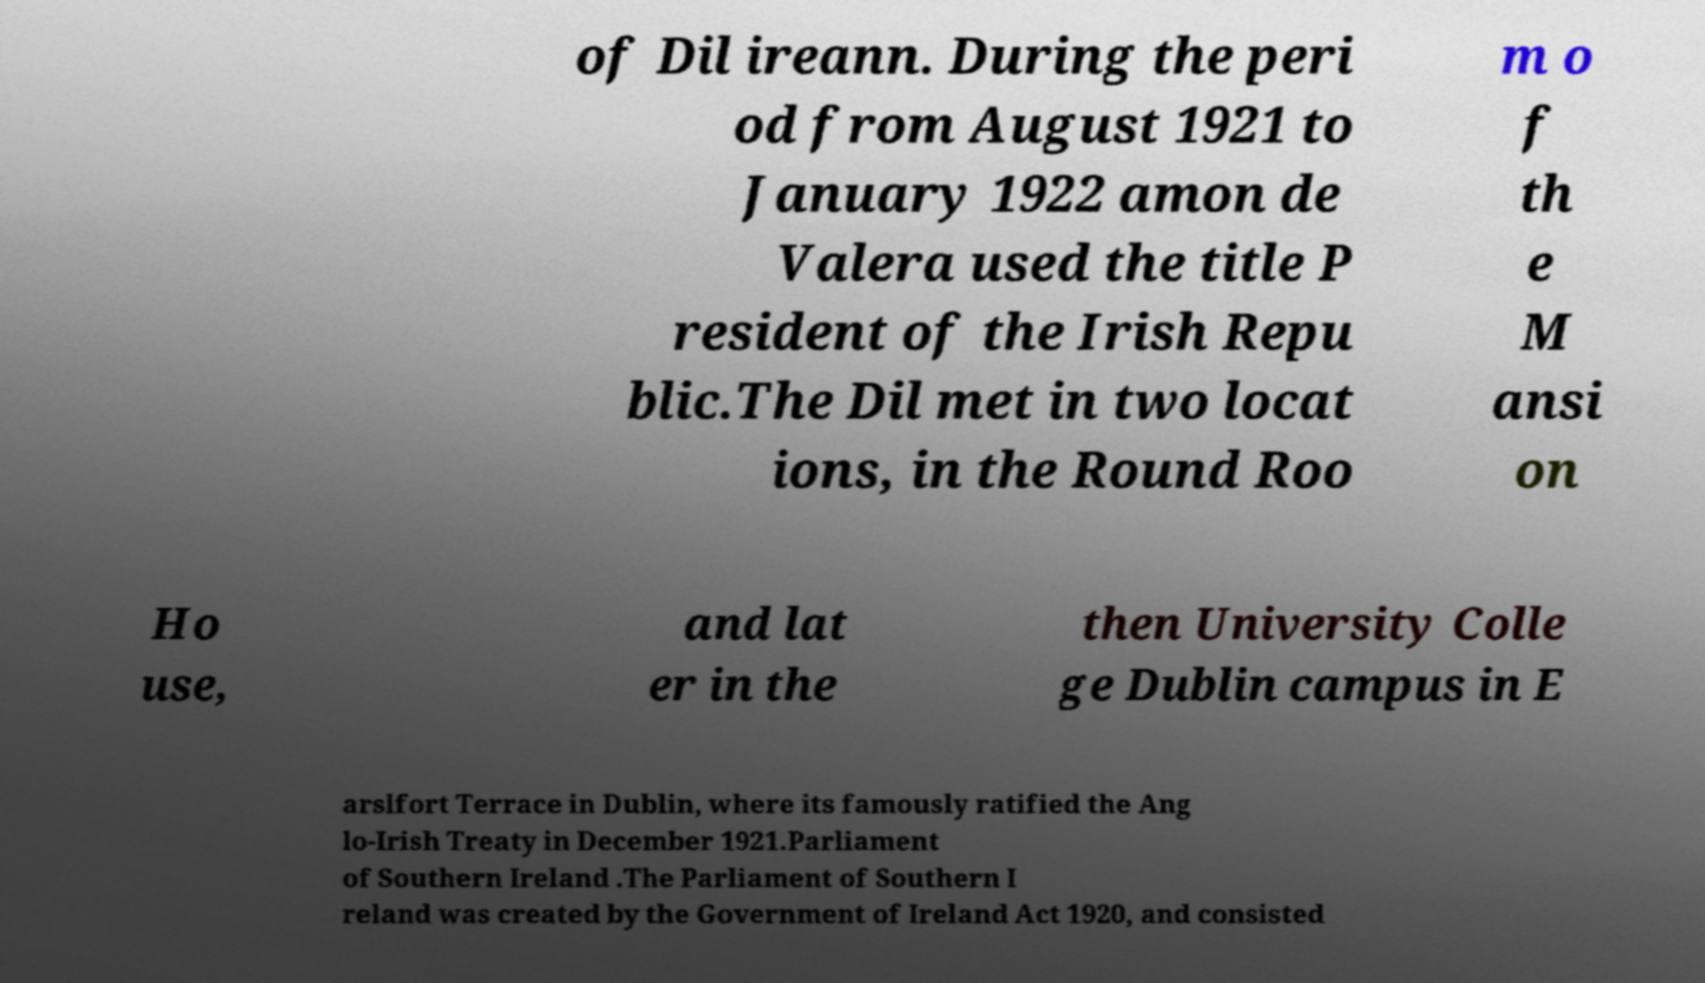Please read and relay the text visible in this image. What does it say? of Dil ireann. During the peri od from August 1921 to January 1922 amon de Valera used the title P resident of the Irish Repu blic.The Dil met in two locat ions, in the Round Roo m o f th e M ansi on Ho use, and lat er in the then University Colle ge Dublin campus in E arslfort Terrace in Dublin, where its famously ratified the Ang lo-Irish Treaty in December 1921.Parliament of Southern Ireland .The Parliament of Southern I reland was created by the Government of Ireland Act 1920, and consisted 